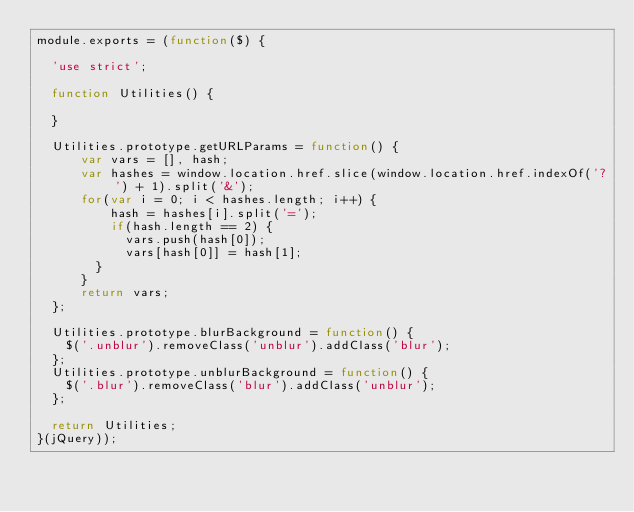Convert code to text. <code><loc_0><loc_0><loc_500><loc_500><_JavaScript_>module.exports = (function($) {

  'use strict';

  function Utilities() {

  }

  Utilities.prototype.getURLParams = function() {
      var vars = [], hash;
      var hashes = window.location.href.slice(window.location.href.indexOf('?') + 1).split('&');
      for(var i = 0; i < hashes.length; i++) {
          hash = hashes[i].split('=');
          if(hash.length == 2) {
  	        vars.push(hash[0]);
  	        vars[hash[0]] = hash[1];
  	    }
      }
      return vars;
  };

  Utilities.prototype.blurBackground = function() {
    $('.unblur').removeClass('unblur').addClass('blur');
  };
  Utilities.prototype.unblurBackground = function() {
    $('.blur').removeClass('blur').addClass('unblur');
  };

  return Utilities;
}(jQuery));
</code> 